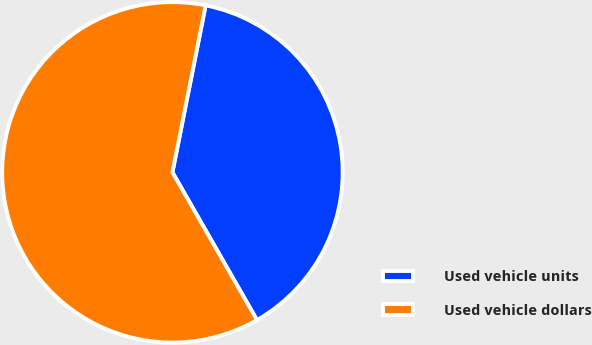<chart> <loc_0><loc_0><loc_500><loc_500><pie_chart><fcel>Used vehicle units<fcel>Used vehicle dollars<nl><fcel>38.6%<fcel>61.4%<nl></chart> 